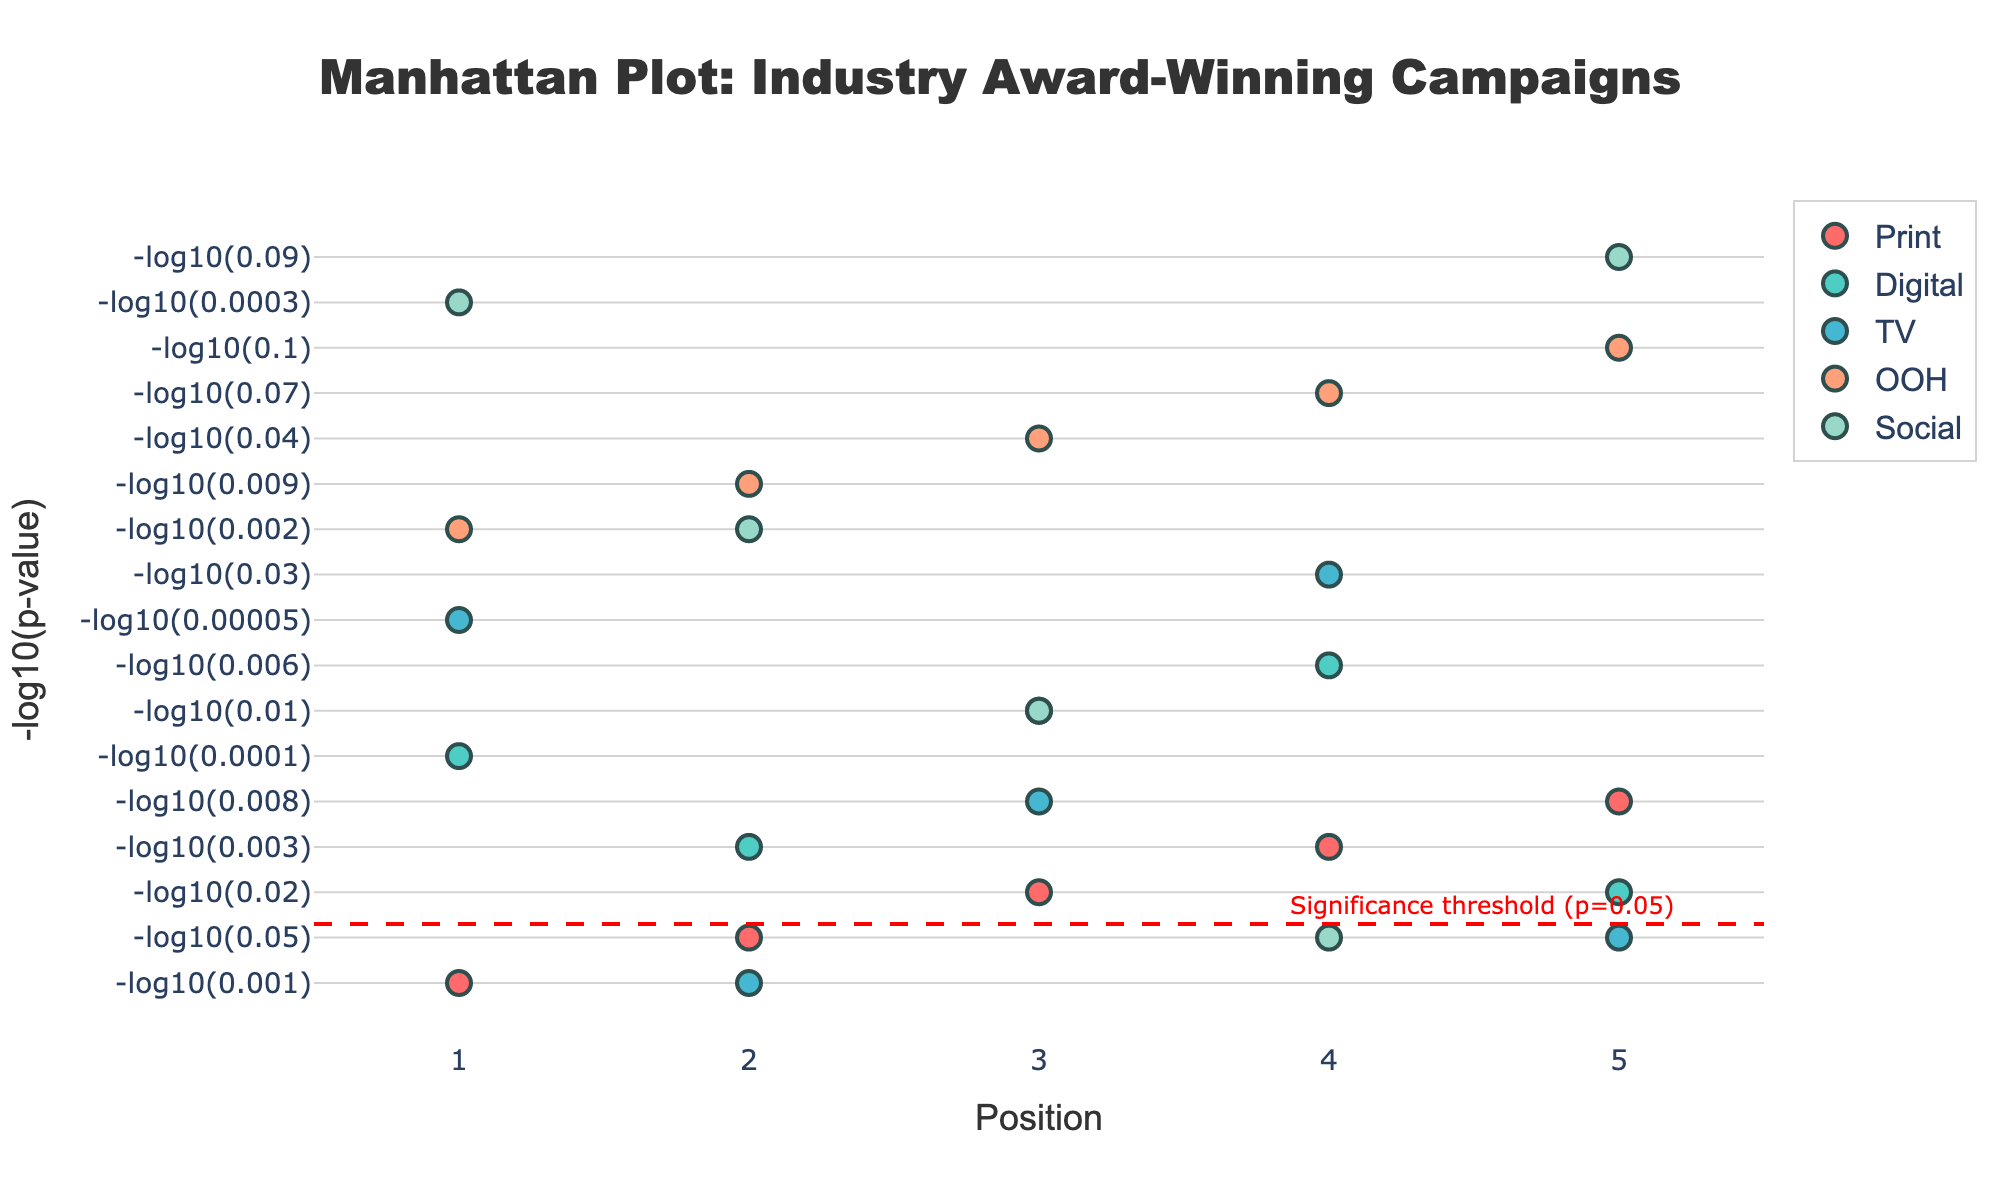What is the title of the plot? The title is prominently displayed at the top of the plot, which reads "Manhattan Plot: Industry Award-Winning Campaigns."
Answer: Manhattan Plot: Industry Award-Winning Campaigns What are the categories represented in the plot? The categories are represented by different colors and listed in the legend. They include Print, Digital, TV, OOH, and Social.
Answer: Print, Digital, TV, OOH, Social Which category has the smallest p-value? The smallest p-value corresponds to the highest -log10(p-value). By inspecting the y-axis, TV has the largest -log10(p-value) with a data point at approximately 4.3.
Answer: TV What is the color of the 'OOH' category in the plot? Each category is represented by a different color. 'OOH' is colored in a shade of orange.
Answer: Orange How many data points are in each category? Each category has exactly 5 data points, which can be observed from the repeated pattern in the x-axis positions.
Answer: 5 Which categories have any data points below the significance threshold line? The significance threshold line is drawn at -log10(0.05). Data points below this line indicate p-values greater than 0.05. For this plot, 'OOH' and 'Social' have data points below this line.
Answer: OOH, Social Which category has the most significant result at Position 1? Position 1 for each category corresponds to the highest point on the y-axis. 'TV' has the highest -log10(p-value) value at Position 1, around 4.3.
Answer: TV What is the LogP value for the 'Social' category at Position 2? The LogP value can be found by looking up 'Social' at Position 2, which is at -log10(0.002), approximately 2.7.
Answer: 2.7 How does the significance of Digital campaigns change from Position 2 to Position 4? To compare, look at the -log10(p-value) for Digital at these positions: -log10(0.003) at Position 2 and -log10(0.006) at Position 4. Both values are relatively high, but Position 4 (around 2.2) is less significant than Position 2 (around 2.5).
Answer: It decreases Which category has the most data points above the significance threshold line? By checking each category's data points against the significance threshold line (-log10(0.05)), 'TV' has all five data points above the line.
Answer: TV 